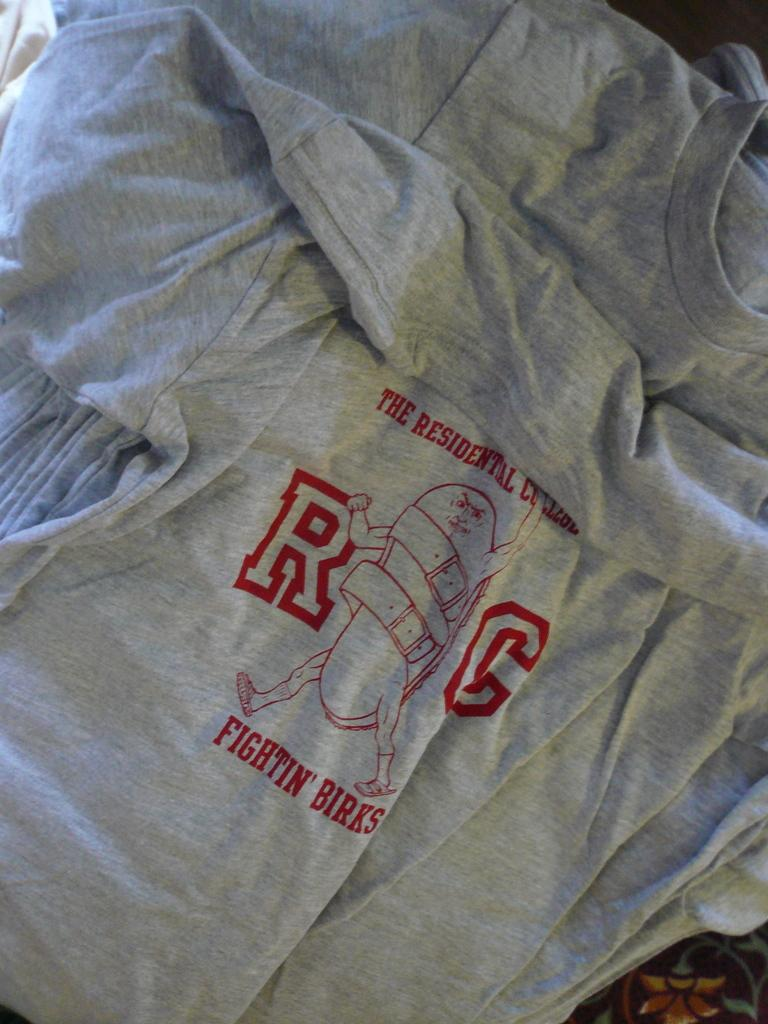<image>
Write a terse but informative summary of the picture. Gray t-shirts laying on the floor with the Fighting Birks logo printed in red on them. 